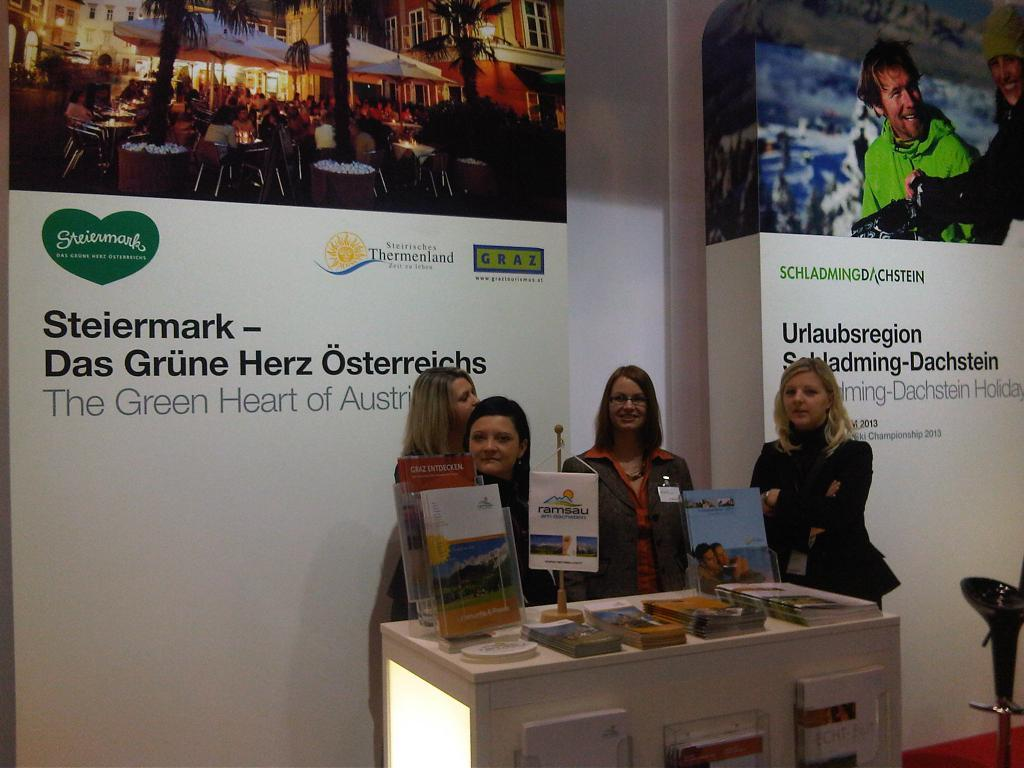What is on the wall in the image? There is a poster on the wall. What is located behind the poster? There is a table behind the poster. Who or what is near the table? There are people standing beside the table. What items can be seen on the table? There are magazines and books on the table. What color is the sock that the sun is wearing in the image? There is no sock or sun present in the image. What topic are the people discussing in the image? The image does not show any discussion or conversation taking place, so we cannot determine the topic. 